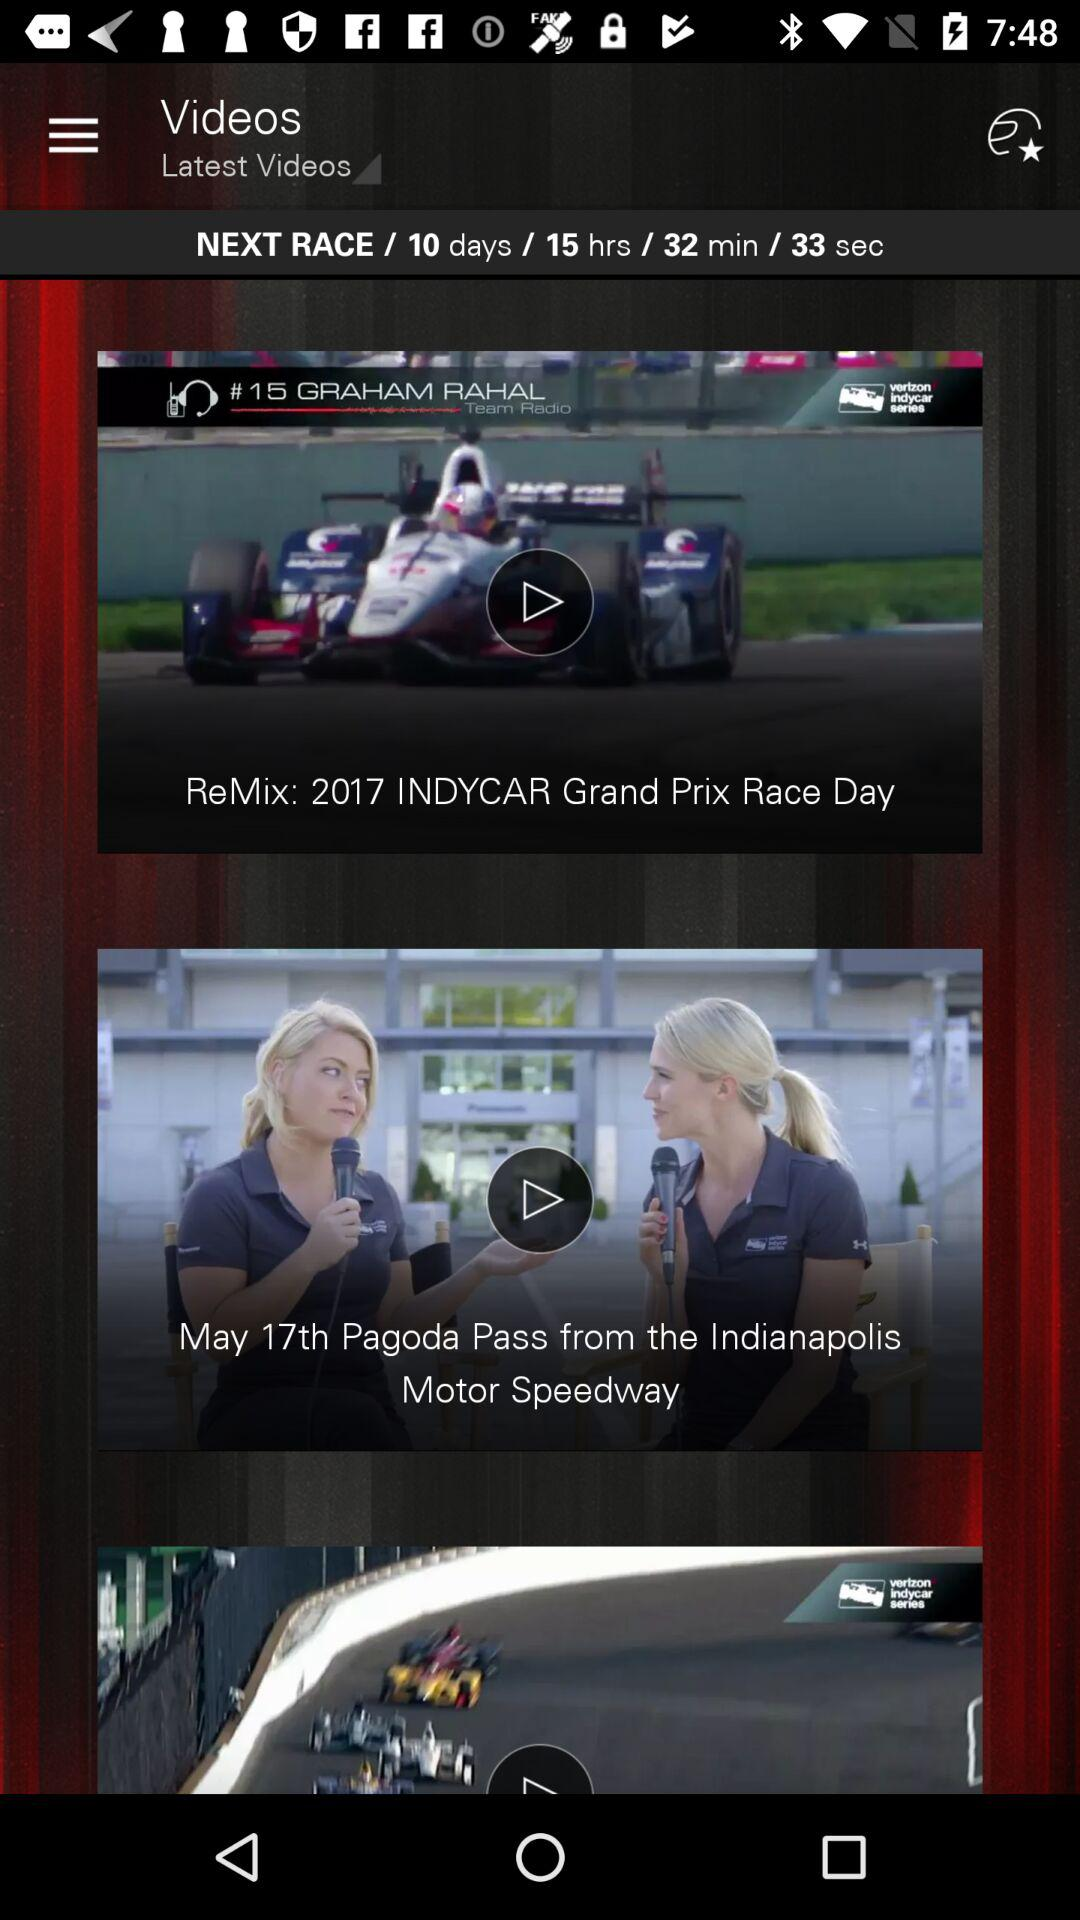What is the date of "Pagoda Pass"? The date of "Pagoda Pass" is May 17. 